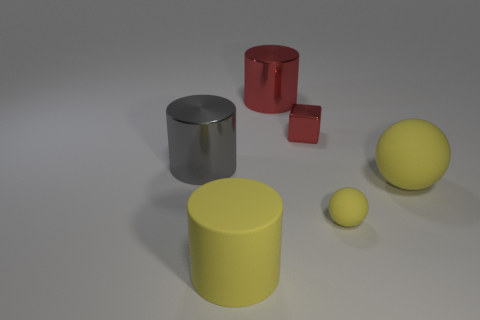Are there any other things that are the same shape as the small red thing?
Your answer should be compact. No. Do the gray metallic cylinder and the rubber ball that is in front of the big rubber sphere have the same size?
Make the answer very short. No. What color is the other big rubber thing that is the same shape as the large gray object?
Offer a very short reply. Yellow. Is the size of the shiny object right of the big red cylinder the same as the yellow rubber ball in front of the large sphere?
Provide a short and direct response. Yes. Is the gray thing the same shape as the small metallic thing?
Provide a succinct answer. No. What number of objects are cylinders right of the big yellow cylinder or large objects?
Give a very brief answer. 4. Are there any large green metallic things of the same shape as the large red object?
Give a very brief answer. No. Are there the same number of yellow rubber cylinders that are right of the big red object and tiny brown cylinders?
Your response must be concise. Yes. There is a shiny thing that is the same color as the cube; what shape is it?
Give a very brief answer. Cylinder. What number of yellow spheres have the same size as the red shiny cylinder?
Give a very brief answer. 1. 